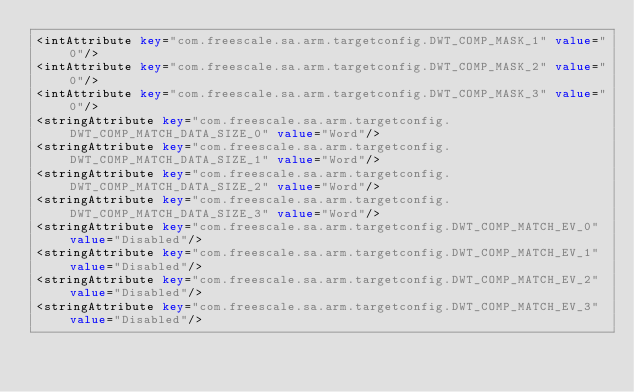Convert code to text. <code><loc_0><loc_0><loc_500><loc_500><_XML_><intAttribute key="com.freescale.sa.arm.targetconfig.DWT_COMP_MASK_1" value="0"/>
<intAttribute key="com.freescale.sa.arm.targetconfig.DWT_COMP_MASK_2" value="0"/>
<intAttribute key="com.freescale.sa.arm.targetconfig.DWT_COMP_MASK_3" value="0"/>
<stringAttribute key="com.freescale.sa.arm.targetconfig.DWT_COMP_MATCH_DATA_SIZE_0" value="Word"/>
<stringAttribute key="com.freescale.sa.arm.targetconfig.DWT_COMP_MATCH_DATA_SIZE_1" value="Word"/>
<stringAttribute key="com.freescale.sa.arm.targetconfig.DWT_COMP_MATCH_DATA_SIZE_2" value="Word"/>
<stringAttribute key="com.freescale.sa.arm.targetconfig.DWT_COMP_MATCH_DATA_SIZE_3" value="Word"/>
<stringAttribute key="com.freescale.sa.arm.targetconfig.DWT_COMP_MATCH_EV_0" value="Disabled"/>
<stringAttribute key="com.freescale.sa.arm.targetconfig.DWT_COMP_MATCH_EV_1" value="Disabled"/>
<stringAttribute key="com.freescale.sa.arm.targetconfig.DWT_COMP_MATCH_EV_2" value="Disabled"/>
<stringAttribute key="com.freescale.sa.arm.targetconfig.DWT_COMP_MATCH_EV_3" value="Disabled"/></code> 